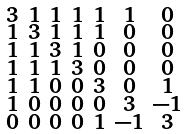Convert formula to latex. <formula><loc_0><loc_0><loc_500><loc_500>\begin{smallmatrix} 3 & 1 & 1 & 1 & 1 & 1 & 0 \\ 1 & 3 & 1 & 1 & 1 & 0 & 0 \\ 1 & 1 & 3 & 1 & 0 & 0 & 0 \\ 1 & 1 & 1 & 3 & 0 & 0 & 0 \\ 1 & 1 & 0 & 0 & 3 & 0 & 1 \\ 1 & 0 & 0 & 0 & 0 & 3 & - 1 \\ 0 & 0 & 0 & 0 & 1 & - 1 & 3 \end{smallmatrix}</formula> 